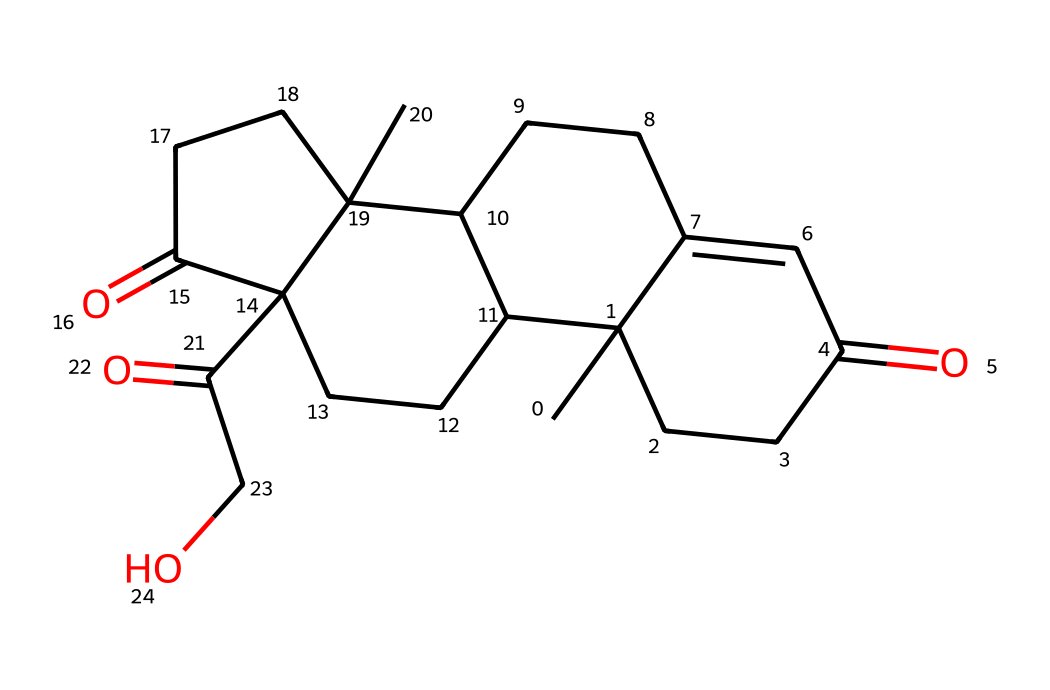What is the molecular formula of cortisol? To determine the molecular formula, we count the number of carbon (C), hydrogen (H), and oxygen (O) atoms in the SMILES representation. In this case, there are 21 carbons, 30 hydrogens, and 5 oxygens. Therefore, the molecular formula is C21H30O5.
Answer: C21H30O5 How many rings does cortisol have in its structure? By inspecting the SMILES notation, we can identify that there are four ring closures indicated by the numbers. So, cortisol contains four rings in its chemical structure.
Answer: 4 Is cortisol an organic compound? Cortisol is composed entirely of carbon, hydrogen, and oxygen, which characterizes it as an organic compound.
Answer: Yes What functional groups are present in cortisol? Looking at the structure, cortisol contains ketone groups (indicated by the presence of C=O) and hydroxyl groups (-OH). Both functional groups are present in the chemical structure of cortisol.
Answer: Ketone and hydroxyl What is the molecular weight of cortisol? To find the molecular weight, we sum the atomic weights of all atoms based on the molecular formula C21H30O5. The calculated weight is approximately 362.46 g/mol.
Answer: 362.46 g/mol How does cortisol affect stress response? Cortisol is known as the stress hormone, released in response to stress; it regulates metabolism, immune response, and helps manage energy supply during stress.
Answer: Regulates stress response Does cortisol have any known side effects when elevated? Elevated cortisol levels can lead to various side effects, including weight gain, high blood pressure, and anxiety.
Answer: Yes 